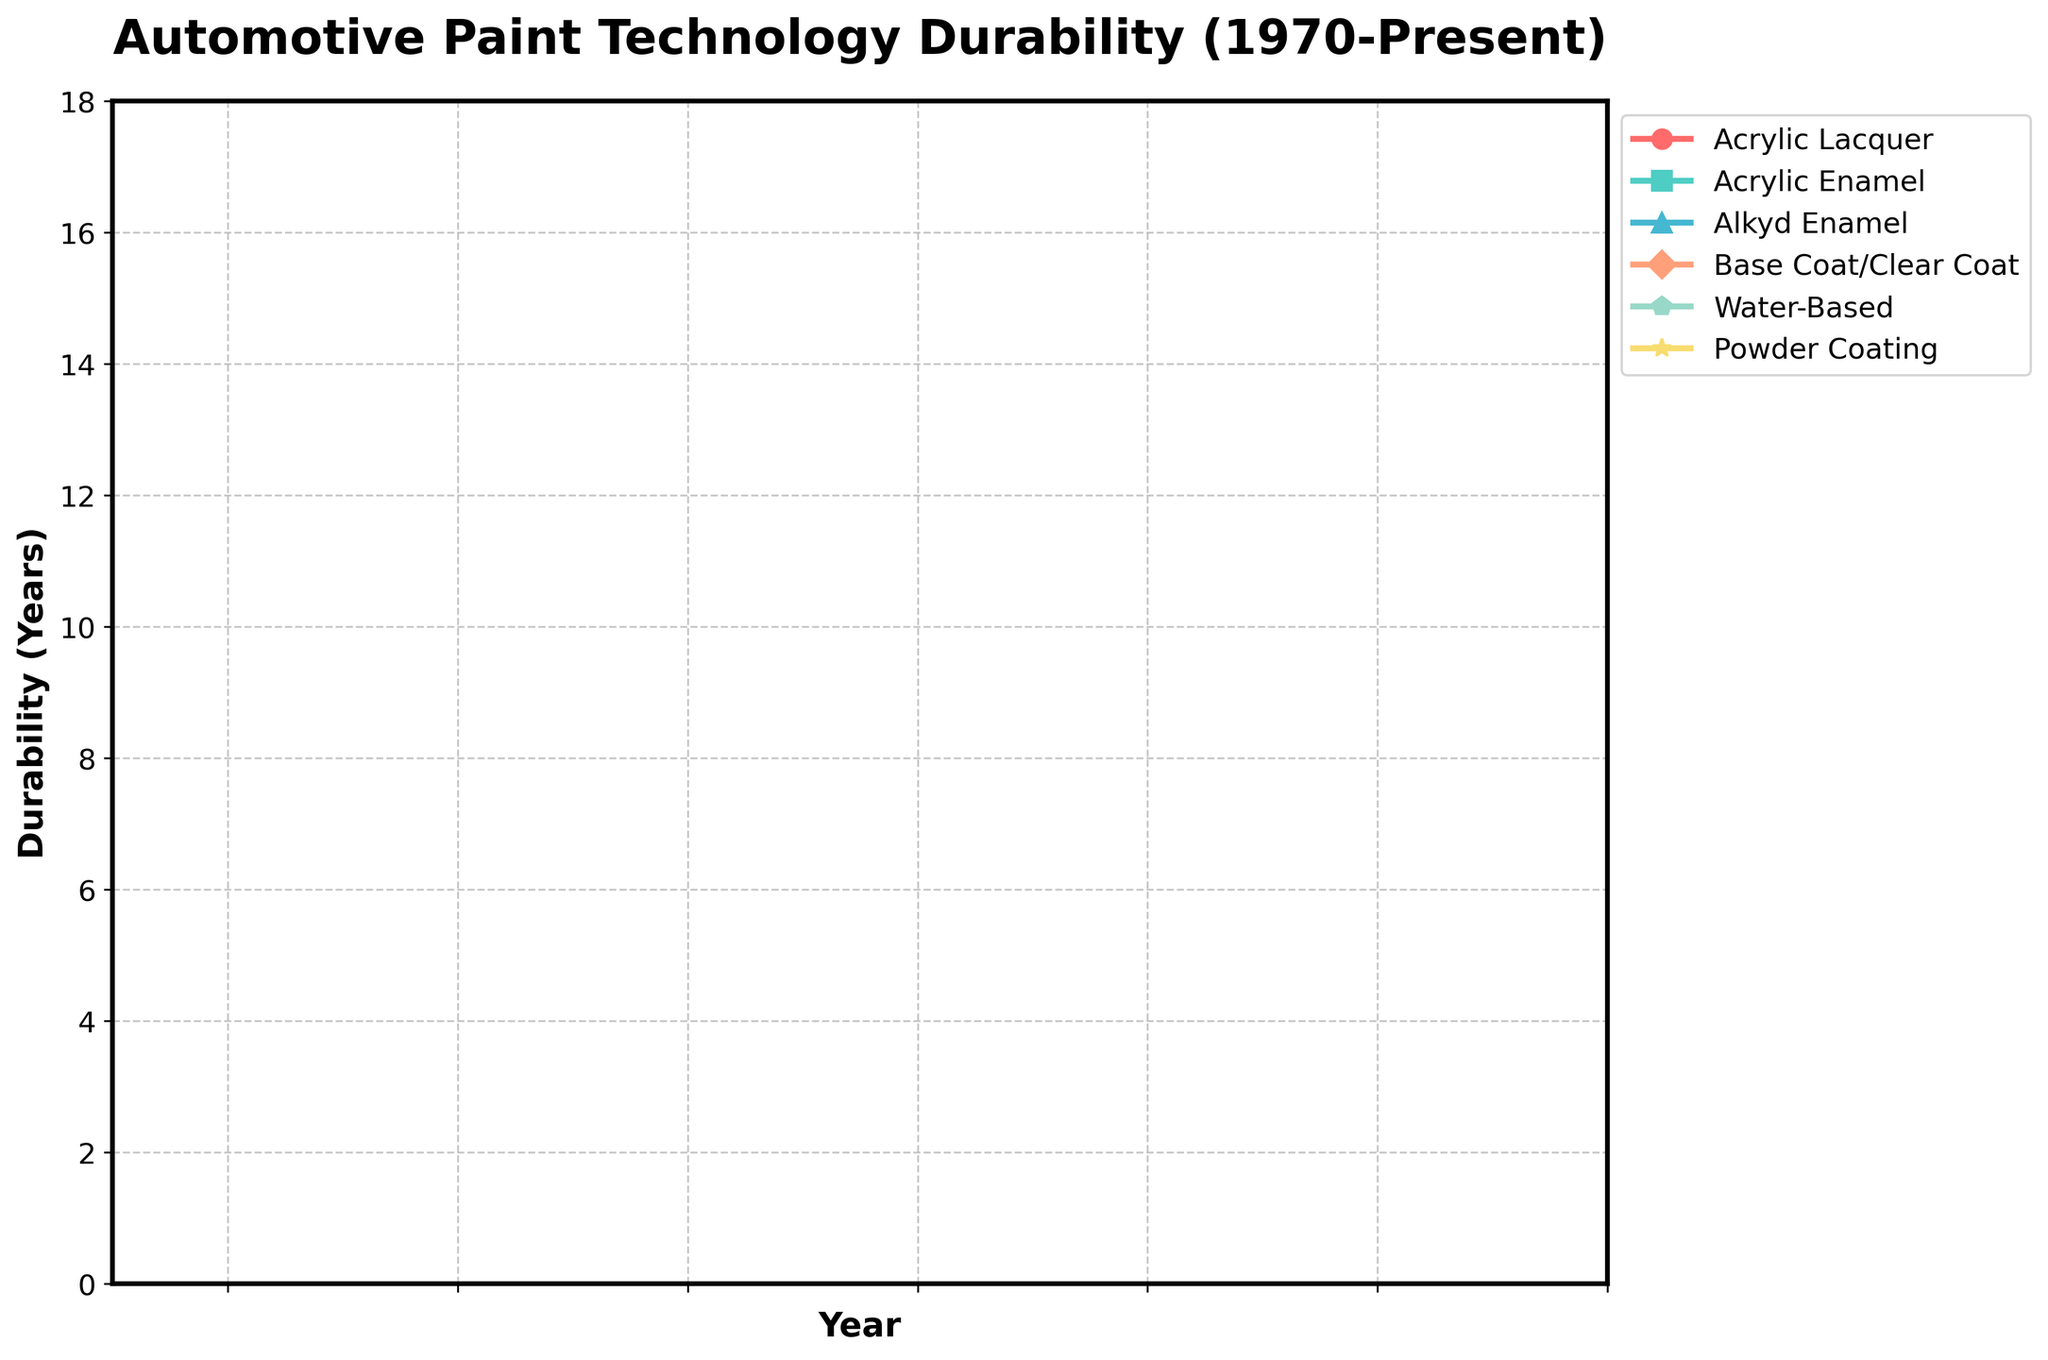What's the durability of Acrylic Enamel paint in 2000? Look at the data point for Acrylic Enamel in the year 2000, which corresponds to a durability value.
Answer: 7 years Which paint technology has shown the most consistent durability since 1980? Check all the paint technologies for their durability values and see which one shows the least fluctuation over the years since 1980. Acrylic Lacquer shows consistent values of 3 to 6.
Answer: Acrylic Lacquer What is the average durability of Water-Based paint from 1990 to the present? Calculate the mean of the Water-Based durability values from 1990 (6) to the present (13): (6+7+8+9+10+11+12+13)/8 = 9.5.
Answer: 9.5 years Which paint technology showed the greatest increase in durability from 1970 to the present? Subtract the 1970 durability values from the present durability values for each paint technology and identify the largest increase: Base Coat/Clear Coat went from 0 in 1970 to 16 in the present.
Answer: Base Coat/Clear Coat From 1990 to 2020, which two paint technologies have consistently improved their durability every subsequent data point? Identify paint technologies that show constant increments in durability values at each data point from 1990 to 2020. Base Coat/Clear Coat and Powder Coating show consistent increases.
Answer: Base Coat/Clear Coat and Powder Coating What is the difference in durability between Acrylic Lacquer and Alkyd Enamel in 2015? Subtract the durability of Acrylic Lacquer (5) from Alkyd Enamel (9) at the year 2015. 9 - 5 = 4.
Answer: 4 years Which paint technology had the highest durability in 1980, and what was it? Find the paint technology with the highest durability value in 1980, which is Base Coat/Clear Coat at 7 years.
Answer: Base Coat/Clear Coat, 7 years What is the combined durability of all paint technologies in the year 2000? Add the durability values of all paint technologies for the year 2000: 4 (Acrylic Lacquer) + 7 (Acrylic Enamel) + 8 (Alkyd Enamel) + 11 (Base Coat/Clear Coat) + 8 (Water-Based) + 10 (Powder Coating) = 48.
Answer: 48 years How does the durability of Powder Coating change from 2000 to the present? Observe the values for Powder Coating from 2000 (10) to the present (15) and note the change.
Answer: Increased by 5 years 